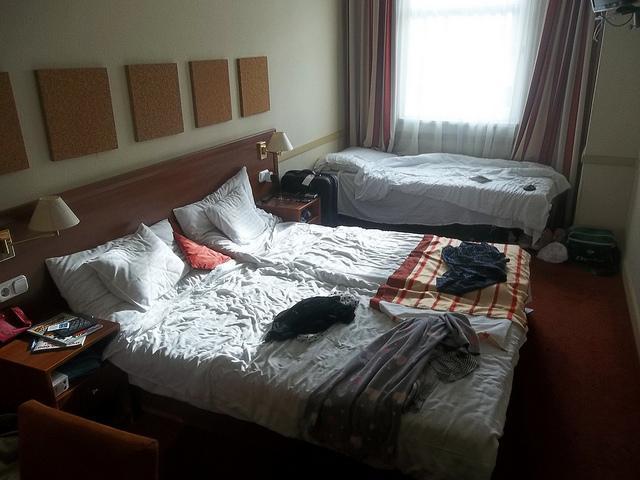How many people are there?
Give a very brief answer. 0. How many beds are in the picture?
Give a very brief answer. 3. 